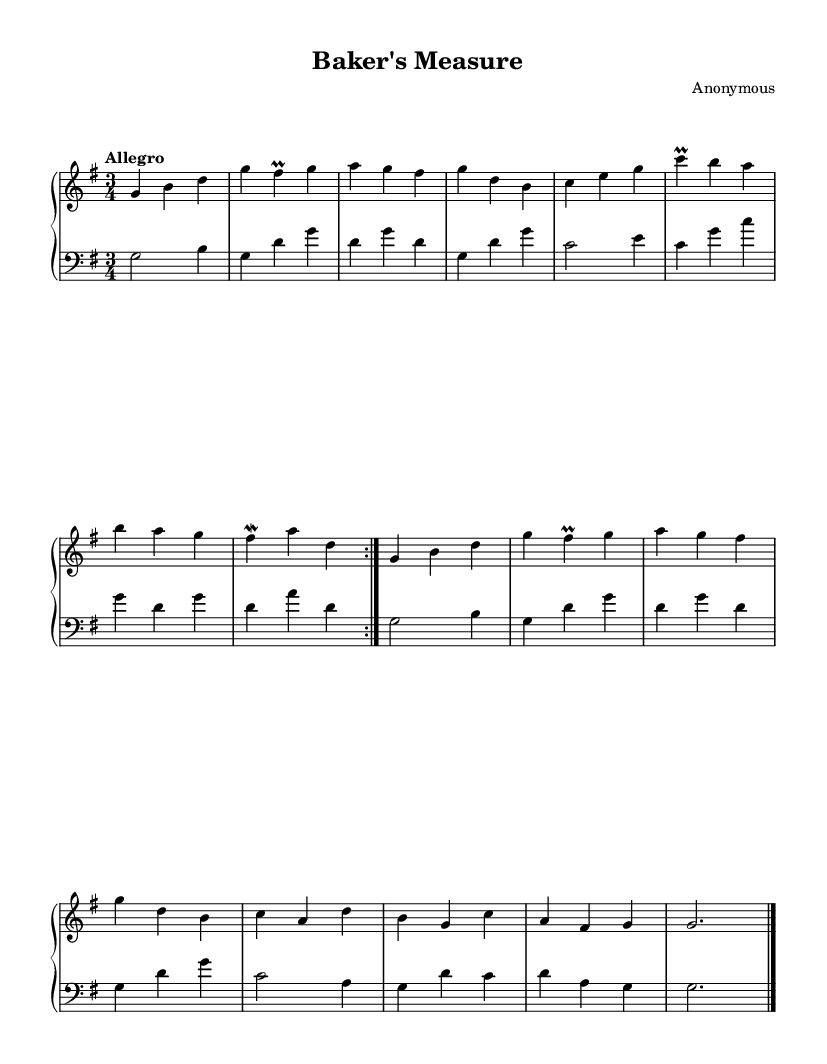What is the key signature of this music? The key signature is G major, which has one sharp (F#). This is identified by looking at the key signature indicated at the beginning of the staff before the notes begin.
Answer: G major What is the time signature of this music? The time signature is 3/4, which means there are three beats in each measure and the quarter note gets one beat. This can be seen at the beginning of the piece, indicated just after the key signature.
Answer: 3/4 What is the tempo marking of this music? The tempo marking is "Allegro," which indicates that the piece should be played quickly and lively. This is noted at the beginning of the music, right under the header.
Answer: Allegro How many times is the upper part repeated? The upper part is repeated two times as indicated by the "repeat volta 2" instruction. This means that the section will play twice in succession before moving on.
Answer: 2 Which ornament is found on the note G in the upper part? The ornament found on the note G is a "prall." This is indicated in the score with the symbol above the note, suggesting a particular embellishment or grace note.
Answer: prall In which section of the piece do the notes move to C, E, and G? The notes move to C, E, and G in the fifth measure of the repeated section. This can be identified by counting the measures and observing where the notes occur.
Answer: Fifth measure What is the final note duration of the piece? The final note duration of the piece is a double whole note, as indicated by the "g2." This notation shows that the last note has a value of two beats and is marked to conclude the piece.
Answer: g2 